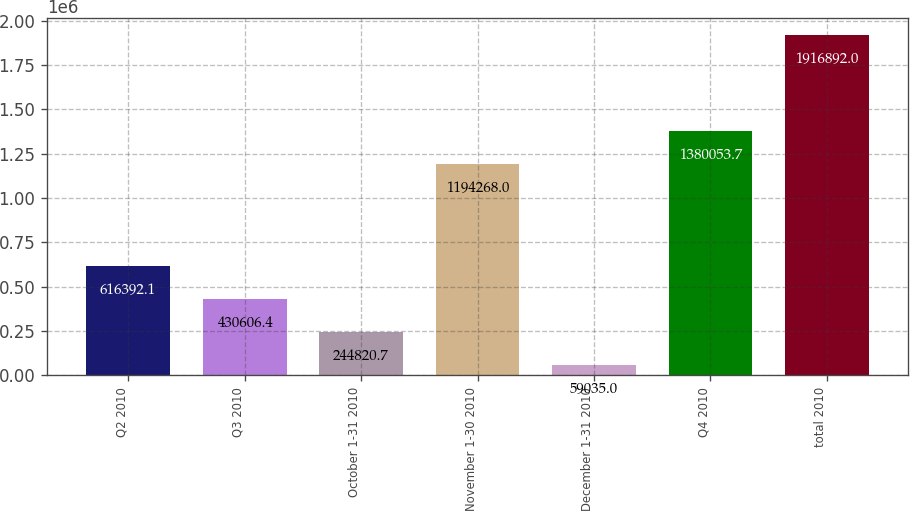Convert chart. <chart><loc_0><loc_0><loc_500><loc_500><bar_chart><fcel>Q2 2010<fcel>Q3 2010<fcel>October 1-31 2010<fcel>November 1-30 2010<fcel>December 1-31 2010<fcel>Q4 2010<fcel>total 2010<nl><fcel>616392<fcel>430606<fcel>244821<fcel>1.19427e+06<fcel>59035<fcel>1.38005e+06<fcel>1.91689e+06<nl></chart> 